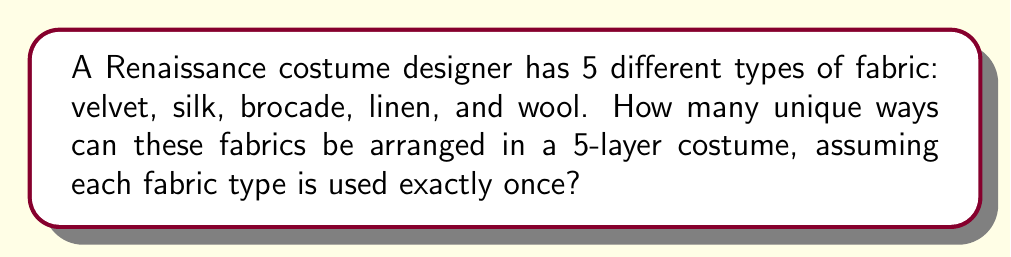Can you answer this question? To solve this problem, we need to use the concept of permutations from combinatorics.

1. We have 5 distinct fabric types, and we want to arrange all of them in a specific order.

2. This scenario is a perfect example of a permutation without repetition, where the order matters and each item is used exactly once.

3. The formula for permutations of n distinct objects is:

   $$P(n) = n!$$

   Where $n!$ represents the factorial of n.

4. In this case, $n = 5$ (for the 5 fabric types).

5. Therefore, the number of unique arrangements is:

   $$P(5) = 5! = 5 \times 4 \times 3 \times 2 \times 1 = 120$$

6. We can interpret this result as follows:
   - For the first layer, we have 5 choices.
   - For the second layer, we have 4 remaining choices.
   - For the third layer, we have 3 remaining choices.
   - For the fourth layer, we have 2 remaining choices.
   - For the last layer, we have only 1 choice left.

7. Multiplying these choices together gives us the total number of unique arrangements: 
   
   $$5 \times 4 \times 3 \times 2 \times 1 = 120$$
Answer: 120 